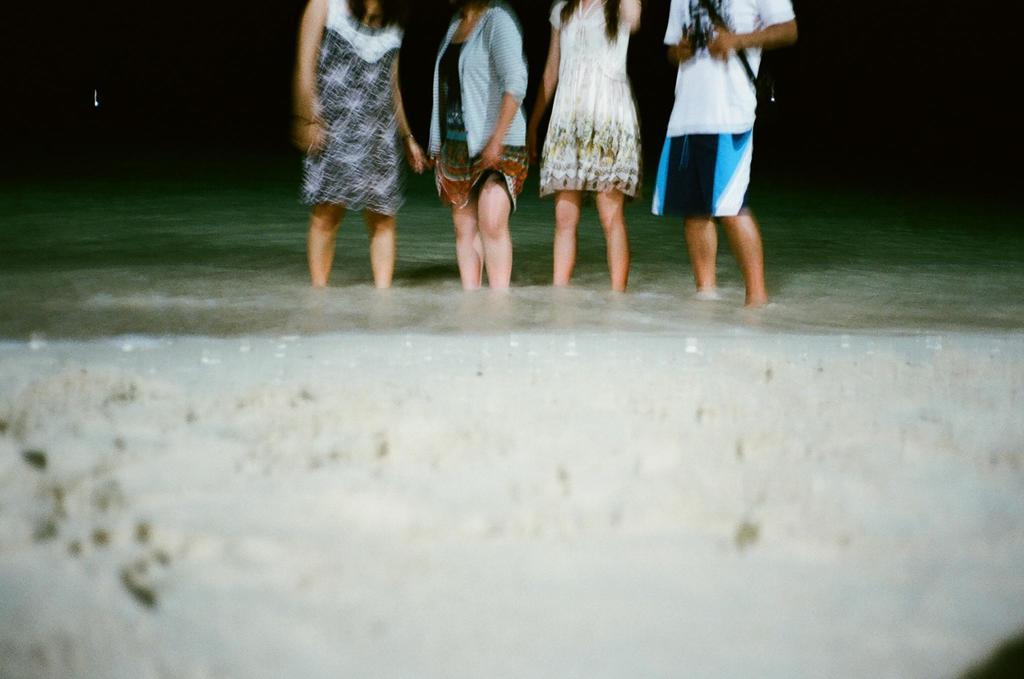How many people are in the image? There are four persons in the image. What are the persons doing in the image? The persons are standing in the water. Can you describe the time of day when the image was taken? The image appears to be taken during the night. Where is the lunchroom located in the image? There is no lunchroom present in the image. How does the beggar interact with the persons in the image? There is no beggar present in the image. 